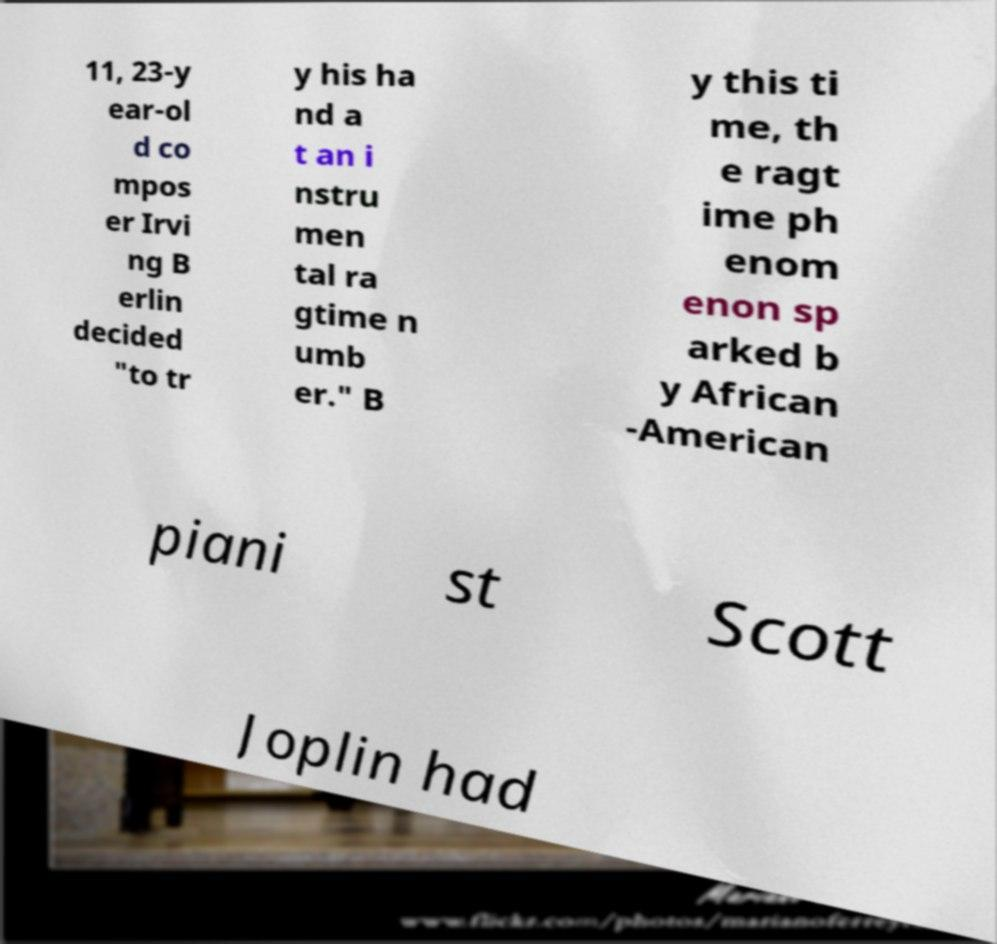Could you assist in decoding the text presented in this image and type it out clearly? 11, 23-y ear-ol d co mpos er Irvi ng B erlin decided "to tr y his ha nd a t an i nstru men tal ra gtime n umb er." B y this ti me, th e ragt ime ph enom enon sp arked b y African -American piani st Scott Joplin had 